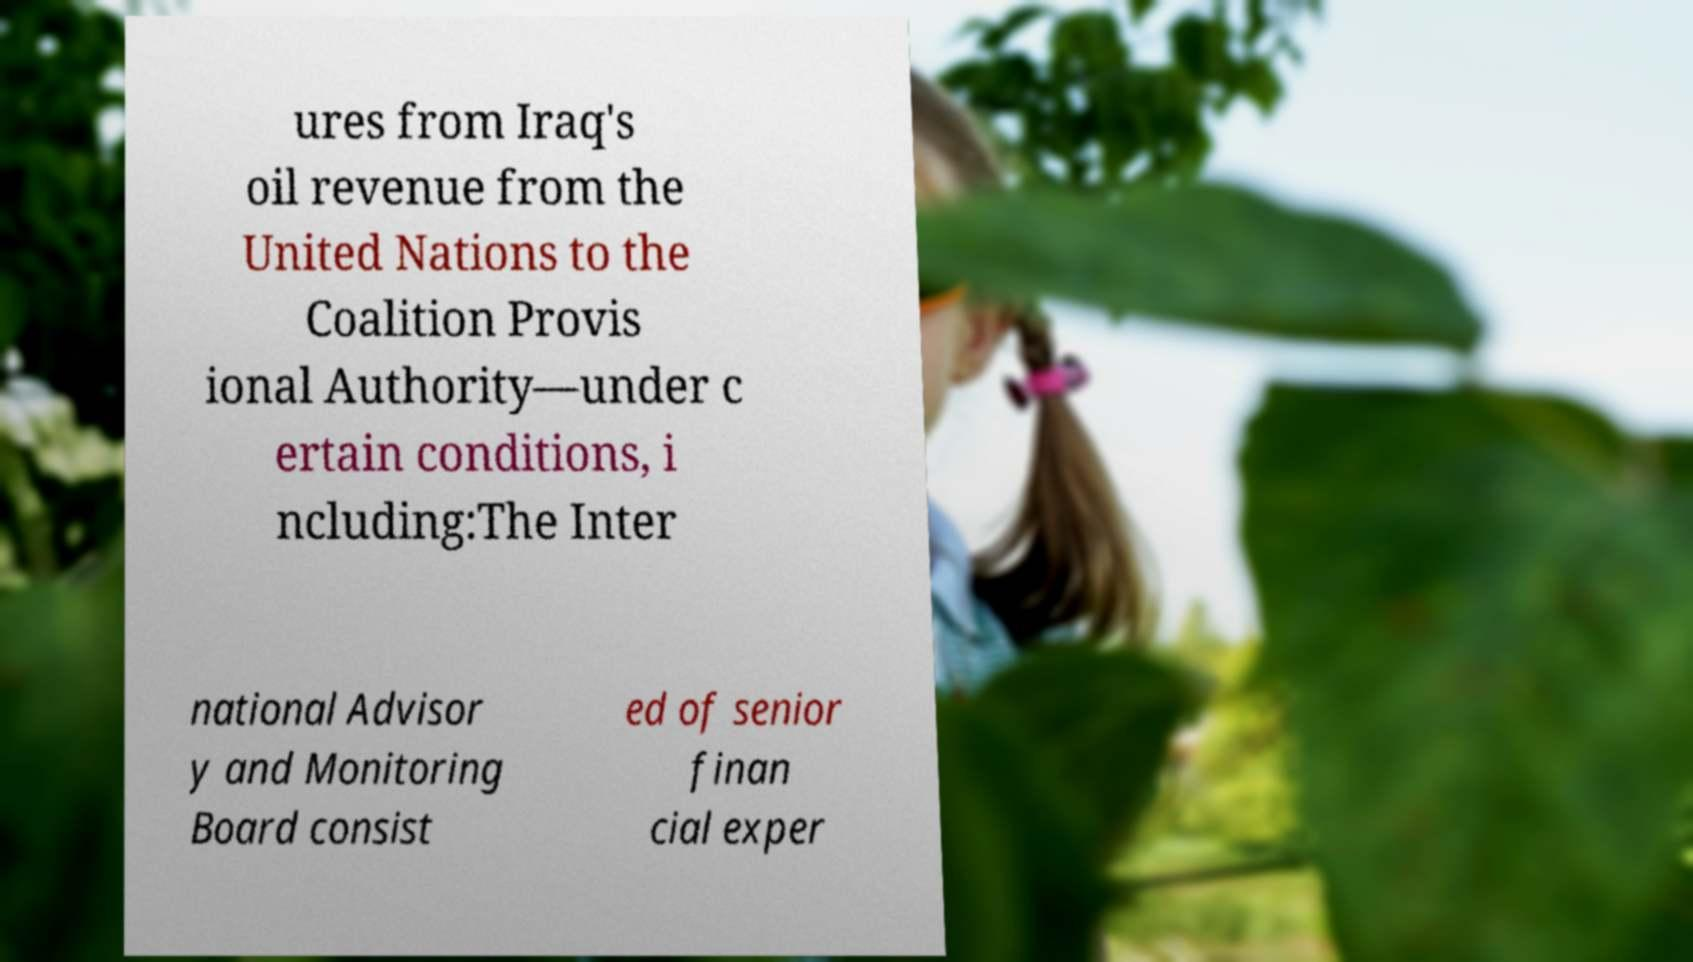Please read and relay the text visible in this image. What does it say? ures from Iraq's oil revenue from the United Nations to the Coalition Provis ional Authority—under c ertain conditions, i ncluding:The Inter national Advisor y and Monitoring Board consist ed of senior finan cial exper 